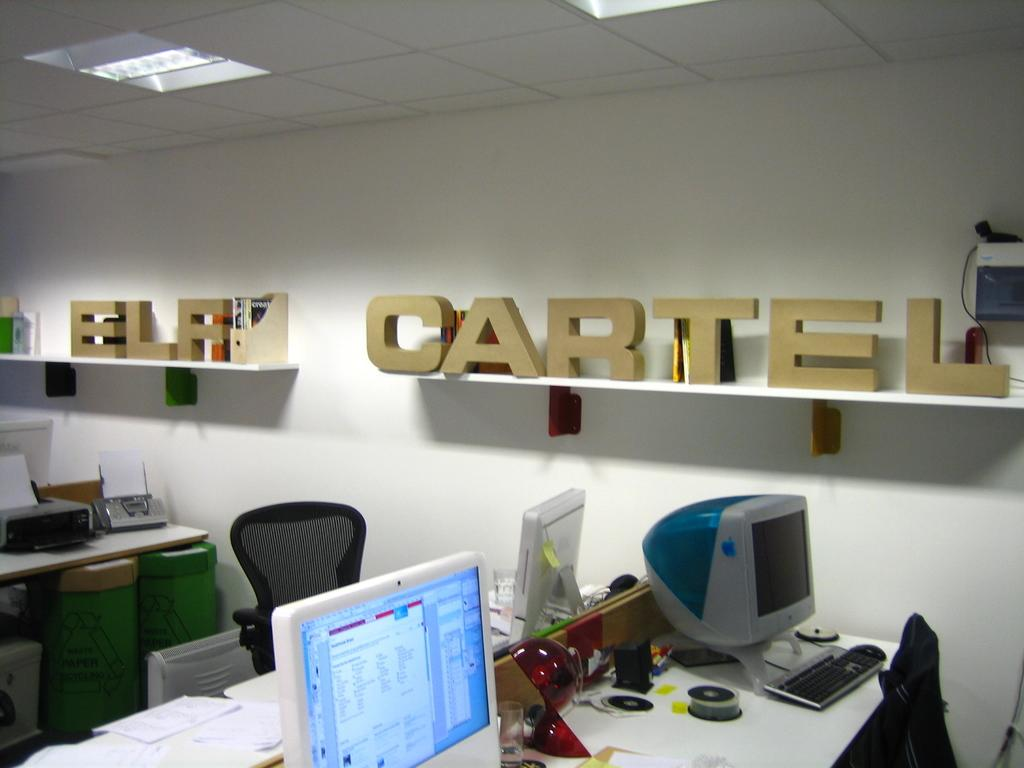Provide a one-sentence caption for the provided image. A office that has ELF CARTEL on a shelf. 